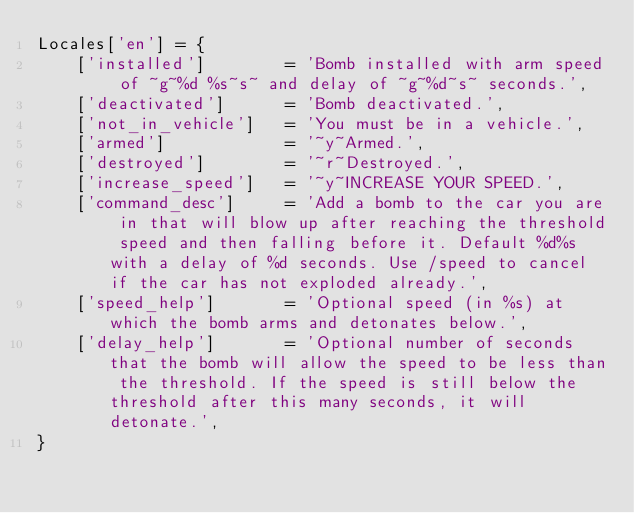<code> <loc_0><loc_0><loc_500><loc_500><_Lua_>Locales['en'] = {
    ['installed']        = 'Bomb installed with arm speed of ~g~%d %s~s~ and delay of ~g~%d~s~ seconds.',
    ['deactivated']      = 'Bomb deactivated.',
    ['not_in_vehicle']   = 'You must be in a vehicle.',
    ['armed']            = '~y~Armed.',
    ['destroyed']        = '~r~Destroyed.',
    ['increase_speed']   = '~y~INCREASE YOUR SPEED.',
    ['command_desc']     = 'Add a bomb to the car you are in that will blow up after reaching the threshold speed and then falling before it. Default %d%s with a delay of %d seconds. Use /speed to cancel if the car has not exploded already.',
    ['speed_help']       = 'Optional speed (in %s) at which the bomb arms and detonates below.',
    ['delay_help']       = 'Optional number of seconds that the bomb will allow the speed to be less than the threshold. If the speed is still below the threshold after this many seconds, it will detonate.',
}
</code> 